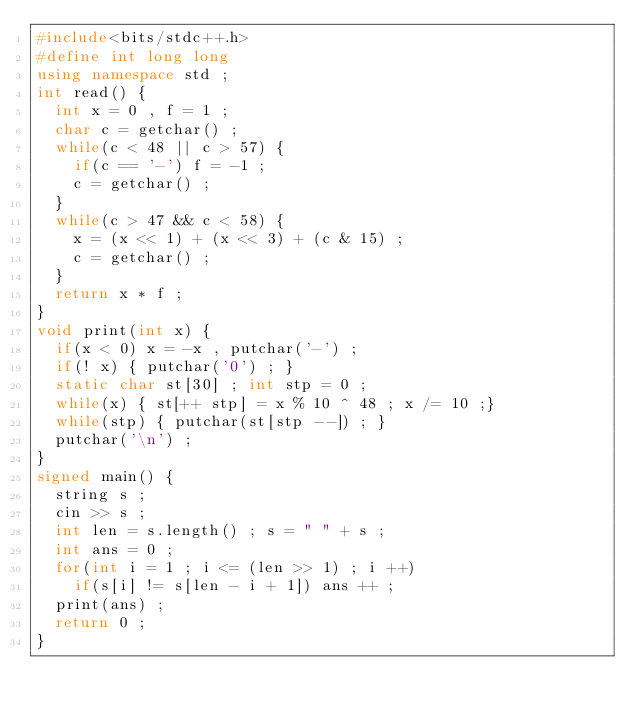Convert code to text. <code><loc_0><loc_0><loc_500><loc_500><_C++_>#include<bits/stdc++.h>
#define int long long
using namespace std ;
int read() {
  int x = 0 , f = 1 ;
  char c = getchar() ;
  while(c < 48 || c > 57) {
    if(c == '-') f = -1 ;
    c = getchar() ;
  }
  while(c > 47 && c < 58) {
    x = (x << 1) + (x << 3) + (c & 15) ;
    c = getchar() ;
  }
  return x * f ;
}
void print(int x) {
  if(x < 0) x = -x , putchar('-') ;
  if(! x) { putchar('0') ; }
  static char st[30] ; int stp = 0 ;
  while(x) { st[++ stp] = x % 10 ^ 48 ; x /= 10 ;}
  while(stp) { putchar(st[stp --]) ; }
  putchar('\n') ;
}
signed main() {
  string s ;
  cin >> s ;
  int len = s.length() ; s = " " + s ;
  int ans = 0 ;
  for(int i = 1 ; i <= (len >> 1) ; i ++)
    if(s[i] != s[len - i + 1]) ans ++ ;
  print(ans) ;
  return 0 ;
}</code> 